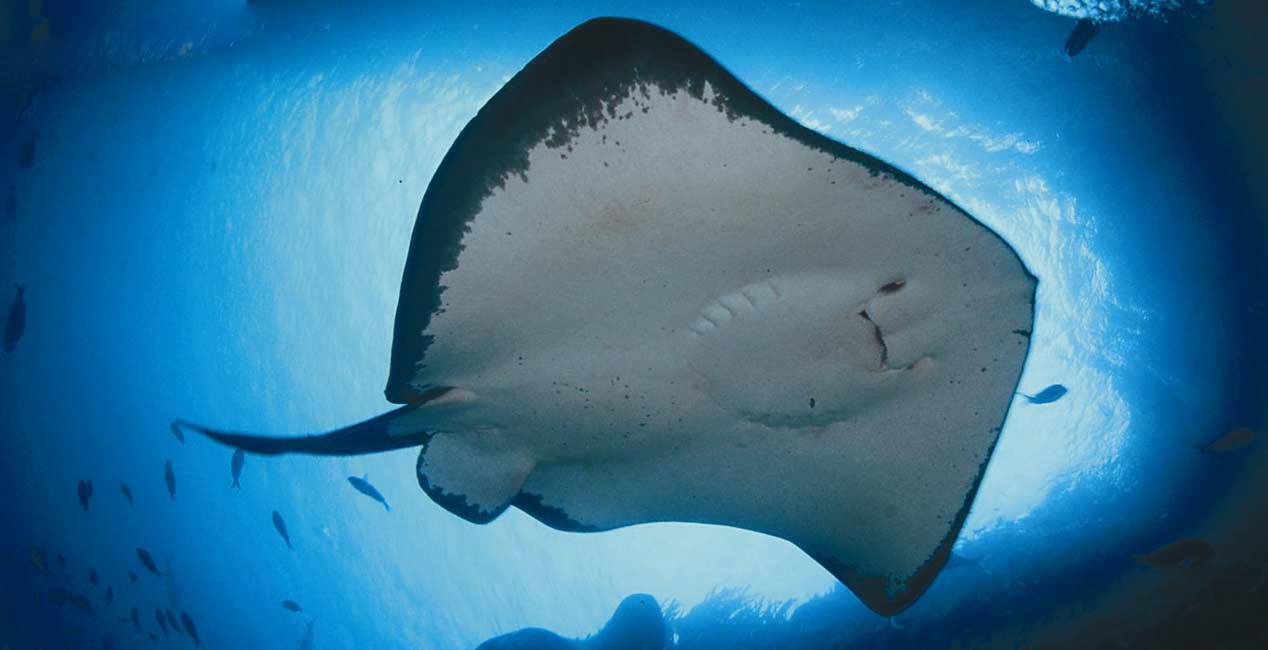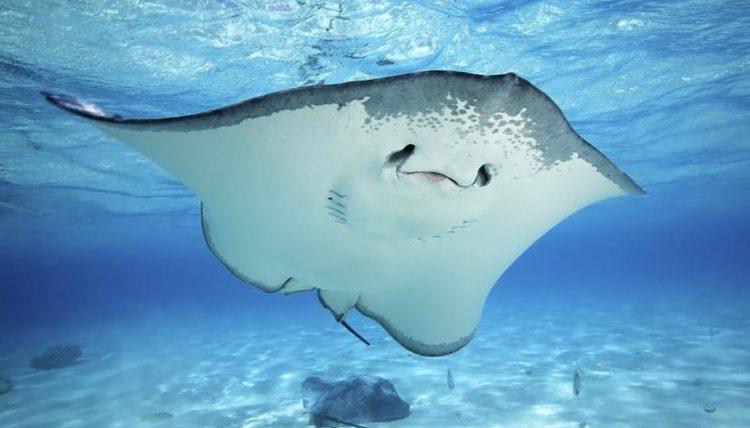The first image is the image on the left, the second image is the image on the right. Assess this claim about the two images: "A total of two stingrays are shown swimming in vivid blue water, with undersides visible.". Correct or not? Answer yes or no. Yes. 